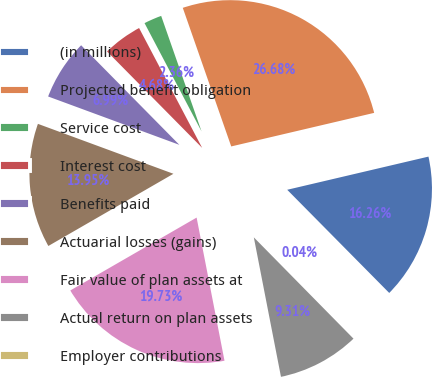<chart> <loc_0><loc_0><loc_500><loc_500><pie_chart><fcel>(in millions)<fcel>Projected benefit obligation<fcel>Service cost<fcel>Interest cost<fcel>Benefits paid<fcel>Actuarial losses (gains)<fcel>Fair value of plan assets at<fcel>Actual return on plan assets<fcel>Employer contributions<nl><fcel>16.26%<fcel>26.68%<fcel>2.36%<fcel>4.68%<fcel>6.99%<fcel>13.95%<fcel>19.73%<fcel>9.31%<fcel>0.04%<nl></chart> 